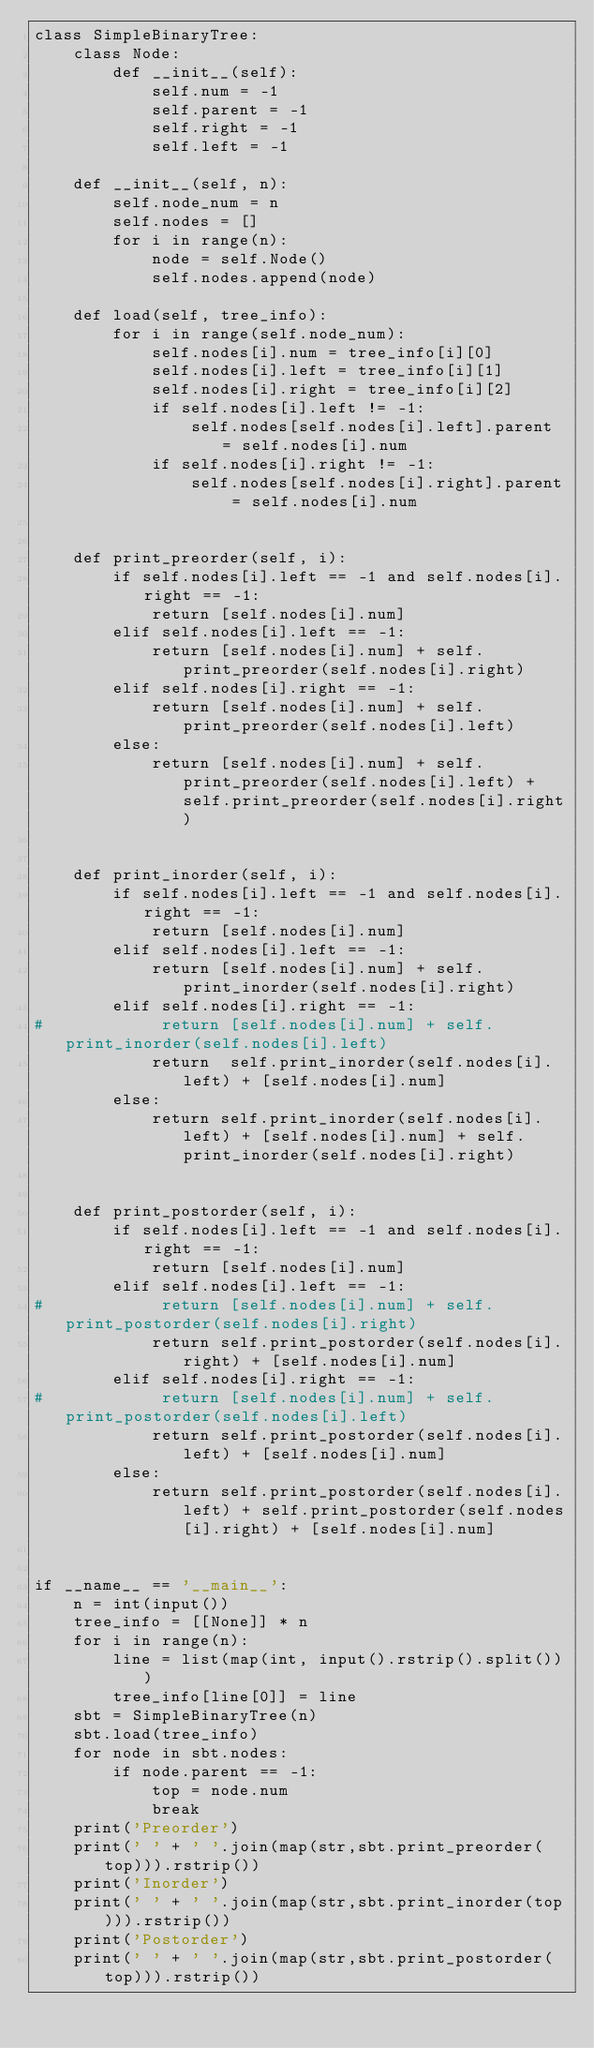<code> <loc_0><loc_0><loc_500><loc_500><_Python_>class SimpleBinaryTree:
    class Node:
        def __init__(self):
            self.num = -1
            self.parent = -1
            self.right = -1
            self.left = -1
    
    def __init__(self, n):
        self.node_num = n
        self.nodes = []
        for i in range(n):
            node = self.Node()
            self.nodes.append(node)
    
    def load(self, tree_info):
        for i in range(self.node_num):
            self.nodes[i].num = tree_info[i][0]
            self.nodes[i].left = tree_info[i][1]
            self.nodes[i].right = tree_info[i][2]
            if self.nodes[i].left != -1:
                self.nodes[self.nodes[i].left].parent = self.nodes[i].num
            if self.nodes[i].right != -1:
                self.nodes[self.nodes[i].right].parent = self.nodes[i].num

    
    def print_preorder(self, i):
        if self.nodes[i].left == -1 and self.nodes[i].right == -1:
            return [self.nodes[i].num]
        elif self.nodes[i].left == -1:
            return [self.nodes[i].num] + self.print_preorder(self.nodes[i].right)
        elif self.nodes[i].right == -1:
            return [self.nodes[i].num] + self.print_preorder(self.nodes[i].left)
        else:
            return [self.nodes[i].num] + self.print_preorder(self.nodes[i].left) + self.print_preorder(self.nodes[i].right)


    def print_inorder(self, i):
        if self.nodes[i].left == -1 and self.nodes[i].right == -1:
            return [self.nodes[i].num]
        elif self.nodes[i].left == -1:
            return [self.nodes[i].num] + self.print_inorder(self.nodes[i].right)
        elif self.nodes[i].right == -1:
#            return [self.nodes[i].num] + self.print_inorder(self.nodes[i].left)
            return  self.print_inorder(self.nodes[i].left) + [self.nodes[i].num]
        else:
            return self.print_inorder(self.nodes[i].left) + [self.nodes[i].num] + self.print_inorder(self.nodes[i].right)


    def print_postorder(self, i):
        if self.nodes[i].left == -1 and self.nodes[i].right == -1:
            return [self.nodes[i].num]
        elif self.nodes[i].left == -1:
#            return [self.nodes[i].num] + self.print_postorder(self.nodes[i].right)
            return self.print_postorder(self.nodes[i].right) + [self.nodes[i].num] 
        elif self.nodes[i].right == -1:
#            return [self.nodes[i].num] + self.print_postorder(self.nodes[i].left)
            return self.print_postorder(self.nodes[i].left) + [self.nodes[i].num]
        else:
            return self.print_postorder(self.nodes[i].left) + self.print_postorder(self.nodes[i].right) + [self.nodes[i].num]


if __name__ == '__main__':
    n = int(input())
    tree_info = [[None]] * n
    for i in range(n):
        line = list(map(int, input().rstrip().split()))
        tree_info[line[0]] = line
    sbt = SimpleBinaryTree(n)
    sbt.load(tree_info)
    for node in sbt.nodes:
        if node.parent == -1:
            top = node.num
            break
    print('Preorder')
    print(' ' + ' '.join(map(str,sbt.print_preorder(top))).rstrip())
    print('Inorder')
    print(' ' + ' '.join(map(str,sbt.print_inorder(top))).rstrip())
    print('Postorder')
    print(' ' + ' '.join(map(str,sbt.print_postorder(top))).rstrip())

</code> 